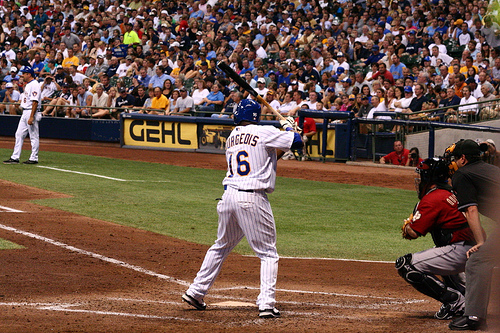<image>What water brand is advertised? It is ambiguous which water brand is advertised. It might be 'gehl', but there also might not be any. What water brand is advertised? There isn't any water brand advertised. 